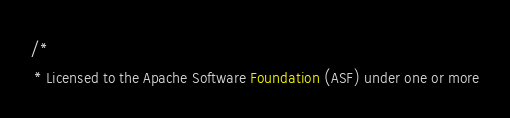Convert code to text. <code><loc_0><loc_0><loc_500><loc_500><_Java_>/*
 * Licensed to the Apache Software Foundation (ASF) under one or more</code> 